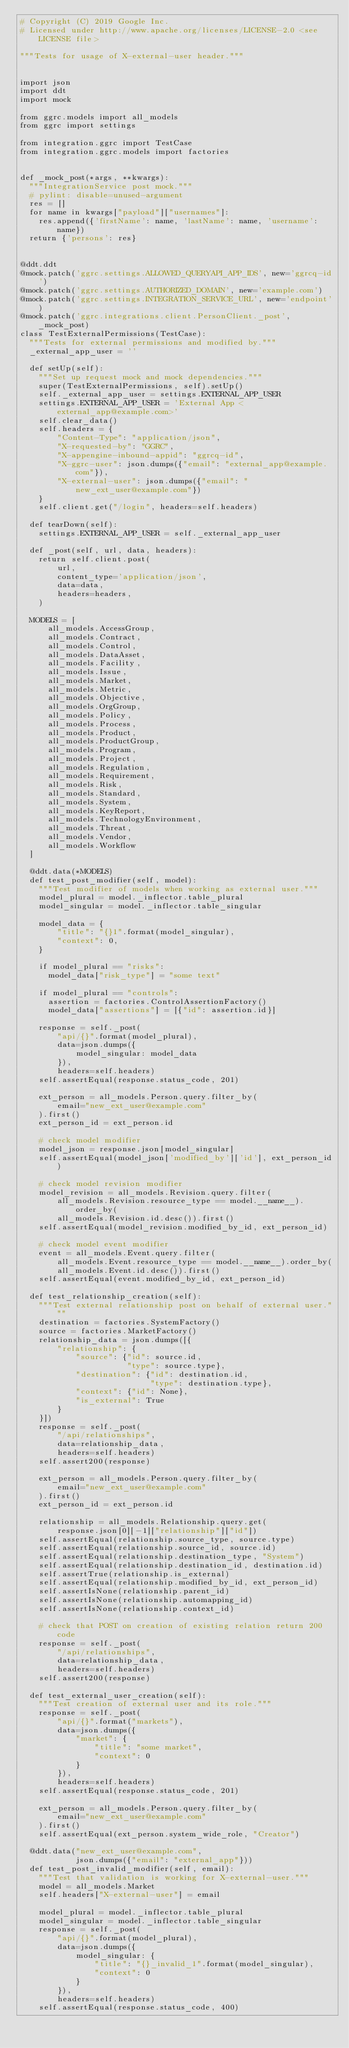Convert code to text. <code><loc_0><loc_0><loc_500><loc_500><_Python_># Copyright (C) 2019 Google Inc.
# Licensed under http://www.apache.org/licenses/LICENSE-2.0 <see LICENSE file>

"""Tests for usage of X-external-user header."""


import json
import ddt
import mock

from ggrc.models import all_models
from ggrc import settings

from integration.ggrc import TestCase
from integration.ggrc.models import factories


def _mock_post(*args, **kwargs):
  """IntegrationService post mock."""
  # pylint: disable=unused-argument
  res = []
  for name in kwargs["payload"]["usernames"]:
    res.append({'firstName': name, 'lastName': name, 'username': name})
  return {'persons': res}


@ddt.ddt
@mock.patch('ggrc.settings.ALLOWED_QUERYAPI_APP_IDS', new='ggrcq-id')
@mock.patch('ggrc.settings.AUTHORIZED_DOMAIN', new='example.com')
@mock.patch('ggrc.settings.INTEGRATION_SERVICE_URL', new='endpoint')
@mock.patch('ggrc.integrations.client.PersonClient._post', _mock_post)
class TestExternalPermissions(TestCase):
  """Tests for external permissions and modified by."""
  _external_app_user = ''

  def setUp(self):
    """Set up request mock and mock dependencies."""
    super(TestExternalPermissions, self).setUp()
    self._external_app_user = settings.EXTERNAL_APP_USER
    settings.EXTERNAL_APP_USER = 'External App <external_app@example.com>'
    self.clear_data()
    self.headers = {
        "Content-Type": "application/json",
        "X-requested-by": "GGRC",
        "X-appengine-inbound-appid": "ggrcq-id",
        "X-ggrc-user": json.dumps({"email": "external_app@example.com"}),
        "X-external-user": json.dumps({"email": "new_ext_user@example.com"})
    }
    self.client.get("/login", headers=self.headers)

  def tearDown(self):
    settings.EXTERNAL_APP_USER = self._external_app_user

  def _post(self, url, data, headers):
    return self.client.post(
        url,
        content_type='application/json',
        data=data,
        headers=headers,
    )

  MODELS = [
      all_models.AccessGroup,
      all_models.Contract,
      all_models.Control,
      all_models.DataAsset,
      all_models.Facility,
      all_models.Issue,
      all_models.Market,
      all_models.Metric,
      all_models.Objective,
      all_models.OrgGroup,
      all_models.Policy,
      all_models.Process,
      all_models.Product,
      all_models.ProductGroup,
      all_models.Program,
      all_models.Project,
      all_models.Regulation,
      all_models.Requirement,
      all_models.Risk,
      all_models.Standard,
      all_models.System,
      all_models.KeyReport,
      all_models.TechnologyEnvironment,
      all_models.Threat,
      all_models.Vendor,
      all_models.Workflow
  ]

  @ddt.data(*MODELS)
  def test_post_modifier(self, model):
    """Test modifier of models when working as external user."""
    model_plural = model._inflector.table_plural
    model_singular = model._inflector.table_singular

    model_data = {
        "title": "{}1".format(model_singular),
        "context": 0,
    }

    if model_plural == "risks":
      model_data["risk_type"] = "some text"

    if model_plural == "controls":
      assertion = factories.ControlAssertionFactory()
      model_data["assertions"] = [{"id": assertion.id}]

    response = self._post(
        "api/{}".format(model_plural),
        data=json.dumps({
            model_singular: model_data
        }),
        headers=self.headers)
    self.assertEqual(response.status_code, 201)

    ext_person = all_models.Person.query.filter_by(
        email="new_ext_user@example.com"
    ).first()
    ext_person_id = ext_person.id

    # check model modifier
    model_json = response.json[model_singular]
    self.assertEqual(model_json['modified_by']['id'], ext_person_id)

    # check model revision modifier
    model_revision = all_models.Revision.query.filter(
        all_models.Revision.resource_type == model.__name__).order_by(
        all_models.Revision.id.desc()).first()
    self.assertEqual(model_revision.modified_by_id, ext_person_id)

    # check model event modifier
    event = all_models.Event.query.filter(
        all_models.Event.resource_type == model.__name__).order_by(
        all_models.Event.id.desc()).first()
    self.assertEqual(event.modified_by_id, ext_person_id)

  def test_relationship_creation(self):
    """Test external relationship post on behalf of external user."""
    destination = factories.SystemFactory()
    source = factories.MarketFactory()
    relationship_data = json.dumps([{
        "relationship": {
            "source": {"id": source.id,
                       "type": source.type},
            "destination": {"id": destination.id,
                            "type": destination.type},
            "context": {"id": None},
            "is_external": True
        }
    }])
    response = self._post(
        "/api/relationships",
        data=relationship_data,
        headers=self.headers)
    self.assert200(response)

    ext_person = all_models.Person.query.filter_by(
        email="new_ext_user@example.com"
    ).first()
    ext_person_id = ext_person.id

    relationship = all_models.Relationship.query.get(
        response.json[0][-1]["relationship"]["id"])
    self.assertEqual(relationship.source_type, source.type)
    self.assertEqual(relationship.source_id, source.id)
    self.assertEqual(relationship.destination_type, "System")
    self.assertEqual(relationship.destination_id, destination.id)
    self.assertTrue(relationship.is_external)
    self.assertEqual(relationship.modified_by_id, ext_person_id)
    self.assertIsNone(relationship.parent_id)
    self.assertIsNone(relationship.automapping_id)
    self.assertIsNone(relationship.context_id)

    # check that POST on creation of existing relation return 200 code
    response = self._post(
        "/api/relationships",
        data=relationship_data,
        headers=self.headers)
    self.assert200(response)

  def test_external_user_creation(self):
    """Test creation of external user and its role."""
    response = self._post(
        "api/{}".format("markets"),
        data=json.dumps({
            "market": {
                "title": "some market",
                "context": 0
            }
        }),
        headers=self.headers)
    self.assertEqual(response.status_code, 201)

    ext_person = all_models.Person.query.filter_by(
        email="new_ext_user@example.com"
    ).first()
    self.assertEqual(ext_person.system_wide_role, "Creator")

  @ddt.data("new_ext_user@example.com",
            json.dumps({"email": "external_app"}))
  def test_post_invalid_modifier(self, email):
    """Test that validation is working for X-external-user."""
    model = all_models.Market
    self.headers["X-external-user"] = email

    model_plural = model._inflector.table_plural
    model_singular = model._inflector.table_singular
    response = self._post(
        "api/{}".format(model_plural),
        data=json.dumps({
            model_singular: {
                "title": "{}_invalid_1".format(model_singular),
                "context": 0
            }
        }),
        headers=self.headers)
    self.assertEqual(response.status_code, 400)
</code> 